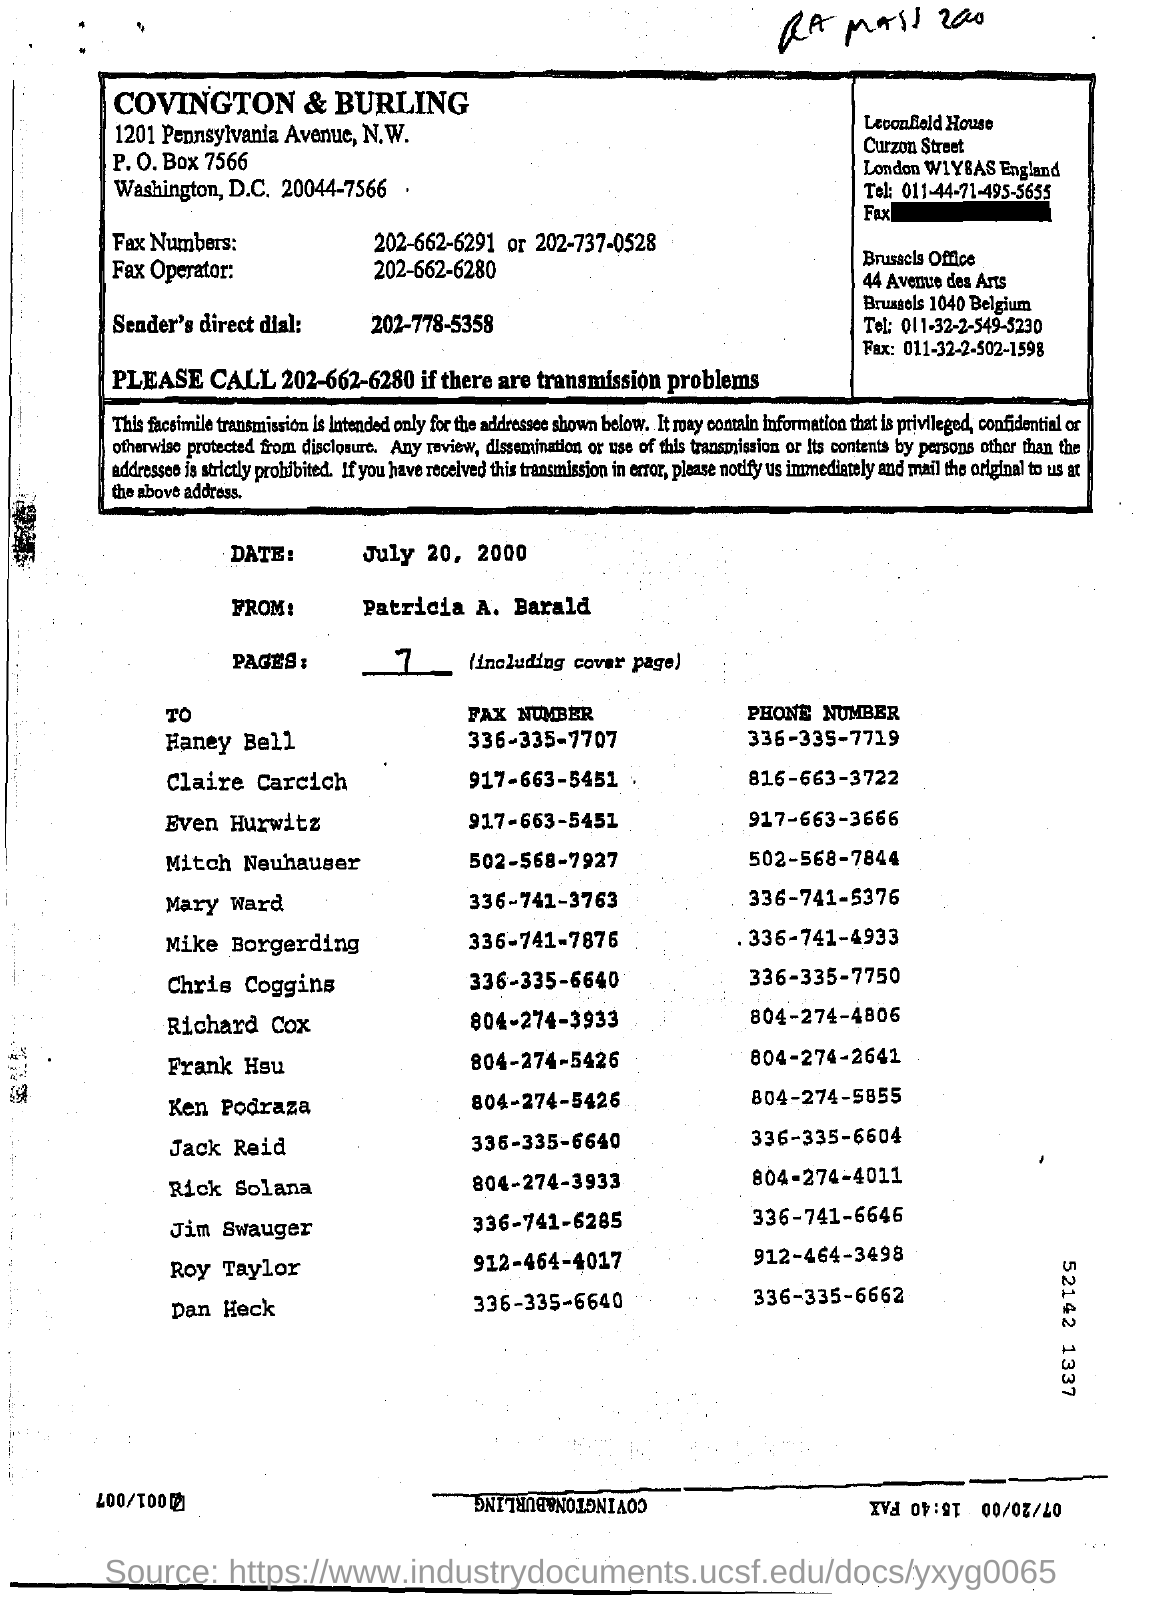What is sender's direct dial?
Offer a very short reply. 202-778-5358. What is date printed in this page?
Keep it short and to the point. July 20, 2000. Number of pages as handwritten?
Keep it short and to the point. 7. What is the fax number of Even Hurwitz?
Keep it short and to the point. 917-663-5451. 